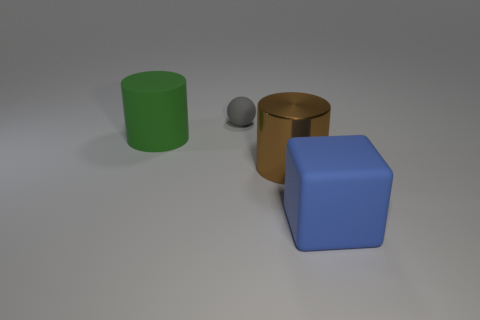Add 4 matte things. How many objects exist? 8 Subtract all spheres. How many objects are left? 3 Add 1 large gray matte objects. How many large gray matte objects exist? 1 Subtract 0 purple balls. How many objects are left? 4 Subtract 1 cylinders. How many cylinders are left? 1 Subtract all brown cylinders. Subtract all blue spheres. How many cylinders are left? 1 Subtract all large green things. Subtract all tiny purple matte things. How many objects are left? 3 Add 1 big rubber blocks. How many big rubber blocks are left? 2 